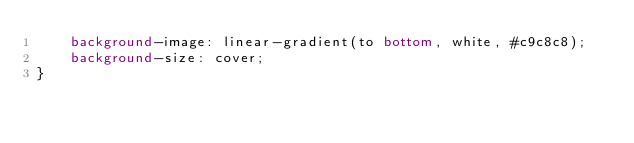<code> <loc_0><loc_0><loc_500><loc_500><_CSS_>    background-image: linear-gradient(to bottom, white, #c9c8c8);
    background-size: cover;
}</code> 